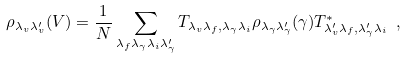Convert formula to latex. <formula><loc_0><loc_0><loc_500><loc_500>\rho _ { \lambda _ { v } \lambda _ { v } ^ { \prime } } ( V ) = \frac { 1 } { N } \sum _ { \lambda _ { f } \lambda _ { \gamma } \lambda _ { i } \lambda _ { \gamma } ^ { \prime } } T _ { \lambda _ { v } \lambda _ { f } , \lambda _ { \gamma } \lambda _ { i } } \rho _ { \lambda _ { \gamma } \lambda _ { \gamma } ^ { \prime } } ( \gamma ) T _ { \lambda _ { v } ^ { \prime } \lambda _ { f } , \lambda _ { \gamma } ^ { \prime } \lambda _ { i } } ^ { * } \ ,</formula> 